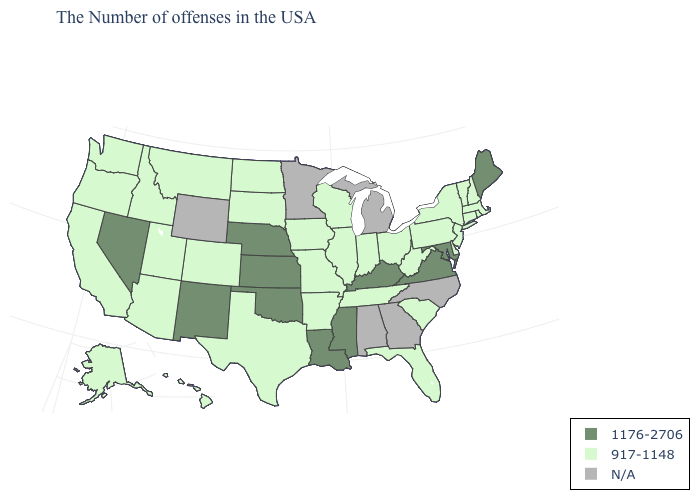What is the value of West Virginia?
Quick response, please. 917-1148. What is the value of Oregon?
Answer briefly. 917-1148. Name the states that have a value in the range 1176-2706?
Keep it brief. Maine, Maryland, Virginia, Kentucky, Mississippi, Louisiana, Kansas, Nebraska, Oklahoma, New Mexico, Nevada. What is the lowest value in the West?
Concise answer only. 917-1148. Name the states that have a value in the range N/A?
Answer briefly. North Carolina, Georgia, Michigan, Alabama, Minnesota, Wyoming. How many symbols are there in the legend?
Concise answer only. 3. Is the legend a continuous bar?
Give a very brief answer. No. What is the value of New Mexico?
Quick response, please. 1176-2706. What is the lowest value in states that border Oregon?
Keep it brief. 917-1148. What is the value of Mississippi?
Answer briefly. 1176-2706. What is the highest value in the West ?
Quick response, please. 1176-2706. Name the states that have a value in the range 1176-2706?
Answer briefly. Maine, Maryland, Virginia, Kentucky, Mississippi, Louisiana, Kansas, Nebraska, Oklahoma, New Mexico, Nevada. What is the lowest value in the USA?
Be succinct. 917-1148. Name the states that have a value in the range 1176-2706?
Short answer required. Maine, Maryland, Virginia, Kentucky, Mississippi, Louisiana, Kansas, Nebraska, Oklahoma, New Mexico, Nevada. Is the legend a continuous bar?
Write a very short answer. No. 